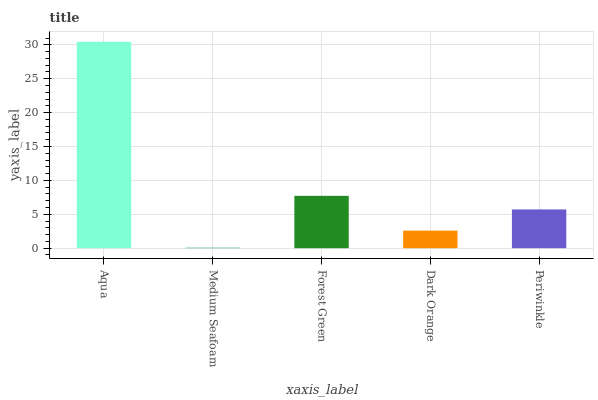Is Forest Green the minimum?
Answer yes or no. No. Is Forest Green the maximum?
Answer yes or no. No. Is Forest Green greater than Medium Seafoam?
Answer yes or no. Yes. Is Medium Seafoam less than Forest Green?
Answer yes or no. Yes. Is Medium Seafoam greater than Forest Green?
Answer yes or no. No. Is Forest Green less than Medium Seafoam?
Answer yes or no. No. Is Periwinkle the high median?
Answer yes or no. Yes. Is Periwinkle the low median?
Answer yes or no. Yes. Is Medium Seafoam the high median?
Answer yes or no. No. Is Aqua the low median?
Answer yes or no. No. 